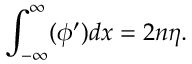Convert formula to latex. <formula><loc_0><loc_0><loc_500><loc_500>\int _ { - \infty } ^ { \infty } ( \phi ^ { \prime } ) d x = 2 n \eta .</formula> 